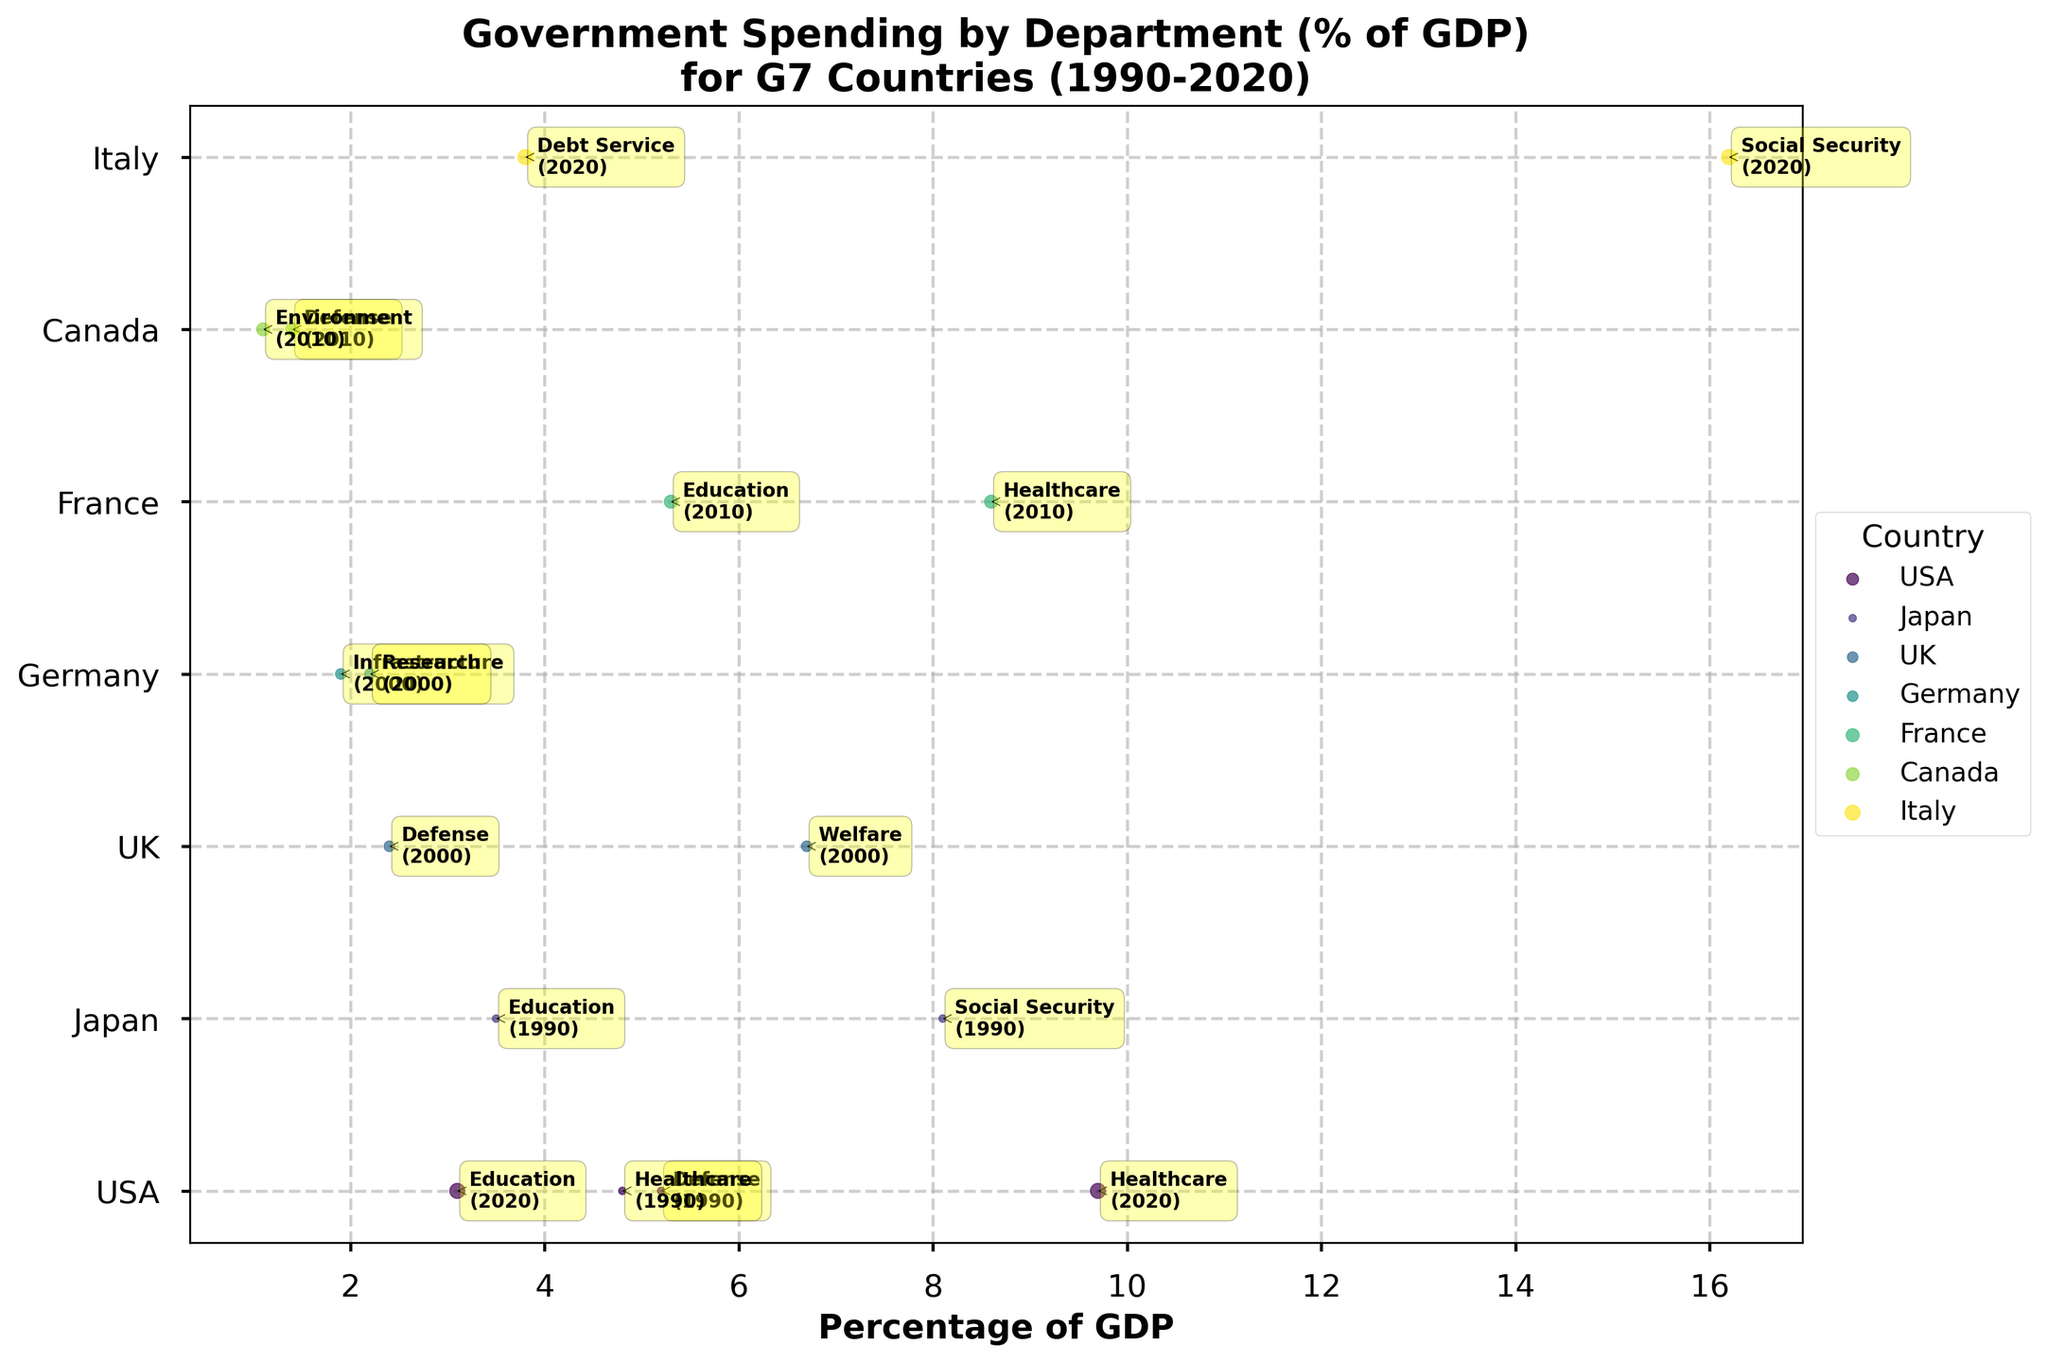What is the country with the highest value of government spending percentage for any department? The department with the highest government spending percentage as seen in the scatter plot is Social Security from Italy in 2020 with a value of 16.2%.
Answer: Italy Which country has the most data points on the graph? By observing the number of annotations and scatter points per country, the USA has the most data points with four represented departments: Defense and Healthcare in 1990, and Healthcare and Education in 2020.
Answer: USA What is the percentage of government spending on Healthcare in the USA in 2020? The annotation next to the corresponding scatter point indicates that the percentage is 9.7% for the USA in 2020.
Answer: 9.7% How does the percentage of government spending on Social Security in Japan in 1990 compare to Italy's spending on the same department in 2020? By comparing the annotations, Japan's Social Security spending in 1990 was 8.1%, whereas Italy’s was 16.2% in 2020. 16.2% is greater than 8.1%.
Answer: Italy's is greater What are the total number of unique departments represented across all countries? Reviewing each annotation and department listed reveals the departments are Defense, Healthcare, Education, Social Security, Welfare, Infrastructure, Research, Environment, and Debt Service, summing to a total of 9 unique departments.
Answer: 9 In which year does France spend the highest on Healthcare? France has only one data point for Healthcare spending, marked in 2010, and the scatter indicates a value of 8.6% for Healthcare in 2010.
Answer: 2010 Compare the government spending percentage on Defense between USA in 1990 and Canada in 2010. The annotations show USA's spending on Defense in 1990 was 5.2% and Canada's spending in 2010 was 1.4%. Hence the USA's spending was higher.
Answer: USA spent more Which department in Japan had the second highest spending as a percentage of GDP? In Japan, the data points covered are Education and Social Security. Comparing 3.5% for Education and 8.1% for Social Security, Education is the second highest.
Answer: Education What is the average percentage of government spending for departments in the UK in 2000? UK's departments in 2000 are Defense (2.4%) and Welfare (6.7%). The average is calculated as (2.4 + 6.7) / 2 = 4.55%.
Answer: 4.55% Which country has the highest percentage of government spending on Debt Service and what is the value? The plot shows Debt Service spending data only for Italy in 2020 with a percentage of 3.8%, making it the highest.
Answer: Italy, 3.8% 